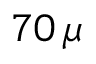Convert formula to latex. <formula><loc_0><loc_0><loc_500><loc_500>7 0 \, \mu</formula> 